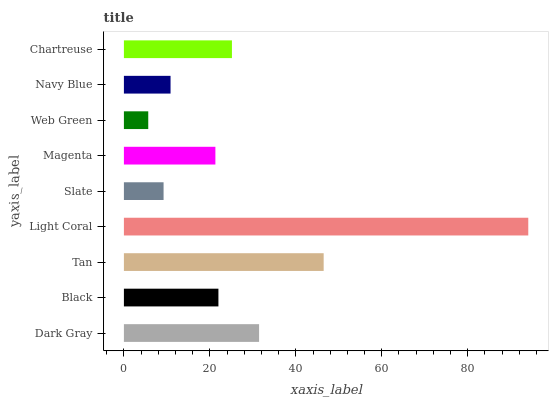Is Web Green the minimum?
Answer yes or no. Yes. Is Light Coral the maximum?
Answer yes or no. Yes. Is Black the minimum?
Answer yes or no. No. Is Black the maximum?
Answer yes or no. No. Is Dark Gray greater than Black?
Answer yes or no. Yes. Is Black less than Dark Gray?
Answer yes or no. Yes. Is Black greater than Dark Gray?
Answer yes or no. No. Is Dark Gray less than Black?
Answer yes or no. No. Is Black the high median?
Answer yes or no. Yes. Is Black the low median?
Answer yes or no. Yes. Is Light Coral the high median?
Answer yes or no. No. Is Dark Gray the low median?
Answer yes or no. No. 